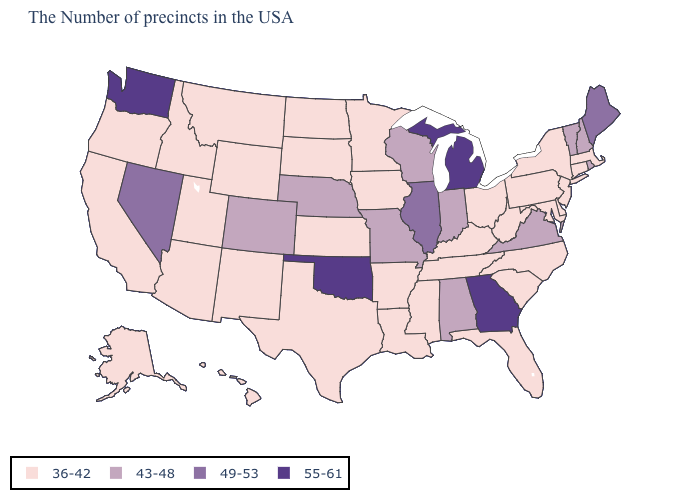Does Minnesota have the highest value in the USA?
Give a very brief answer. No. Which states have the lowest value in the MidWest?
Give a very brief answer. Ohio, Minnesota, Iowa, Kansas, South Dakota, North Dakota. How many symbols are there in the legend?
Answer briefly. 4. Is the legend a continuous bar?
Give a very brief answer. No. What is the lowest value in states that border Nevada?
Be succinct. 36-42. Name the states that have a value in the range 49-53?
Short answer required. Maine, Illinois, Nevada. What is the value of North Carolina?
Write a very short answer. 36-42. What is the lowest value in the West?
Be succinct. 36-42. What is the value of Oklahoma?
Be succinct. 55-61. What is the value of New York?
Write a very short answer. 36-42. Does Delaware have the lowest value in the South?
Give a very brief answer. Yes. Does the map have missing data?
Write a very short answer. No. Which states have the lowest value in the USA?
Quick response, please. Massachusetts, Connecticut, New York, New Jersey, Delaware, Maryland, Pennsylvania, North Carolina, South Carolina, West Virginia, Ohio, Florida, Kentucky, Tennessee, Mississippi, Louisiana, Arkansas, Minnesota, Iowa, Kansas, Texas, South Dakota, North Dakota, Wyoming, New Mexico, Utah, Montana, Arizona, Idaho, California, Oregon, Alaska, Hawaii. Name the states that have a value in the range 43-48?
Quick response, please. Rhode Island, New Hampshire, Vermont, Virginia, Indiana, Alabama, Wisconsin, Missouri, Nebraska, Colorado. 